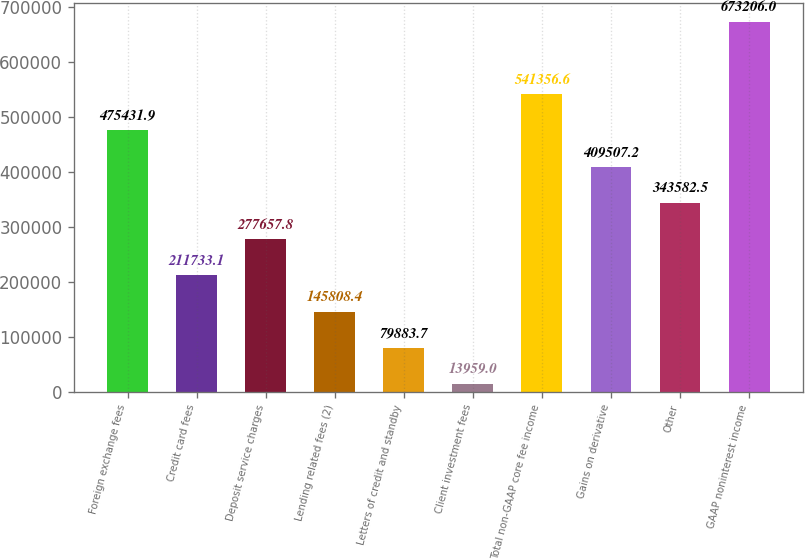<chart> <loc_0><loc_0><loc_500><loc_500><bar_chart><fcel>Foreign exchange fees<fcel>Credit card fees<fcel>Deposit service charges<fcel>Lending related fees (2)<fcel>Letters of credit and standby<fcel>Client investment fees<fcel>Total non-GAAP core fee income<fcel>Gains on derivative<fcel>Other<fcel>GAAP noninterest income<nl><fcel>475432<fcel>211733<fcel>277658<fcel>145808<fcel>79883.7<fcel>13959<fcel>541357<fcel>409507<fcel>343582<fcel>673206<nl></chart> 